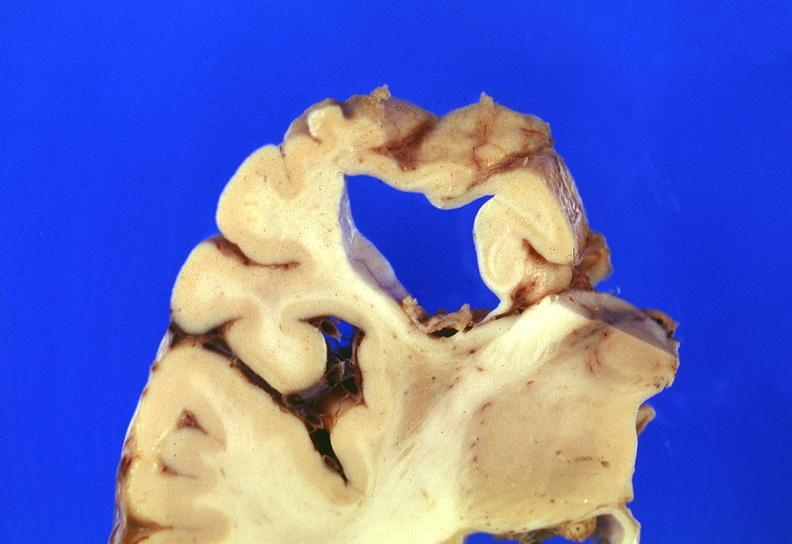does saggital section typical show brain, frontal lobe atrophy, pick 's disease?
Answer the question using a single word or phrase. No 